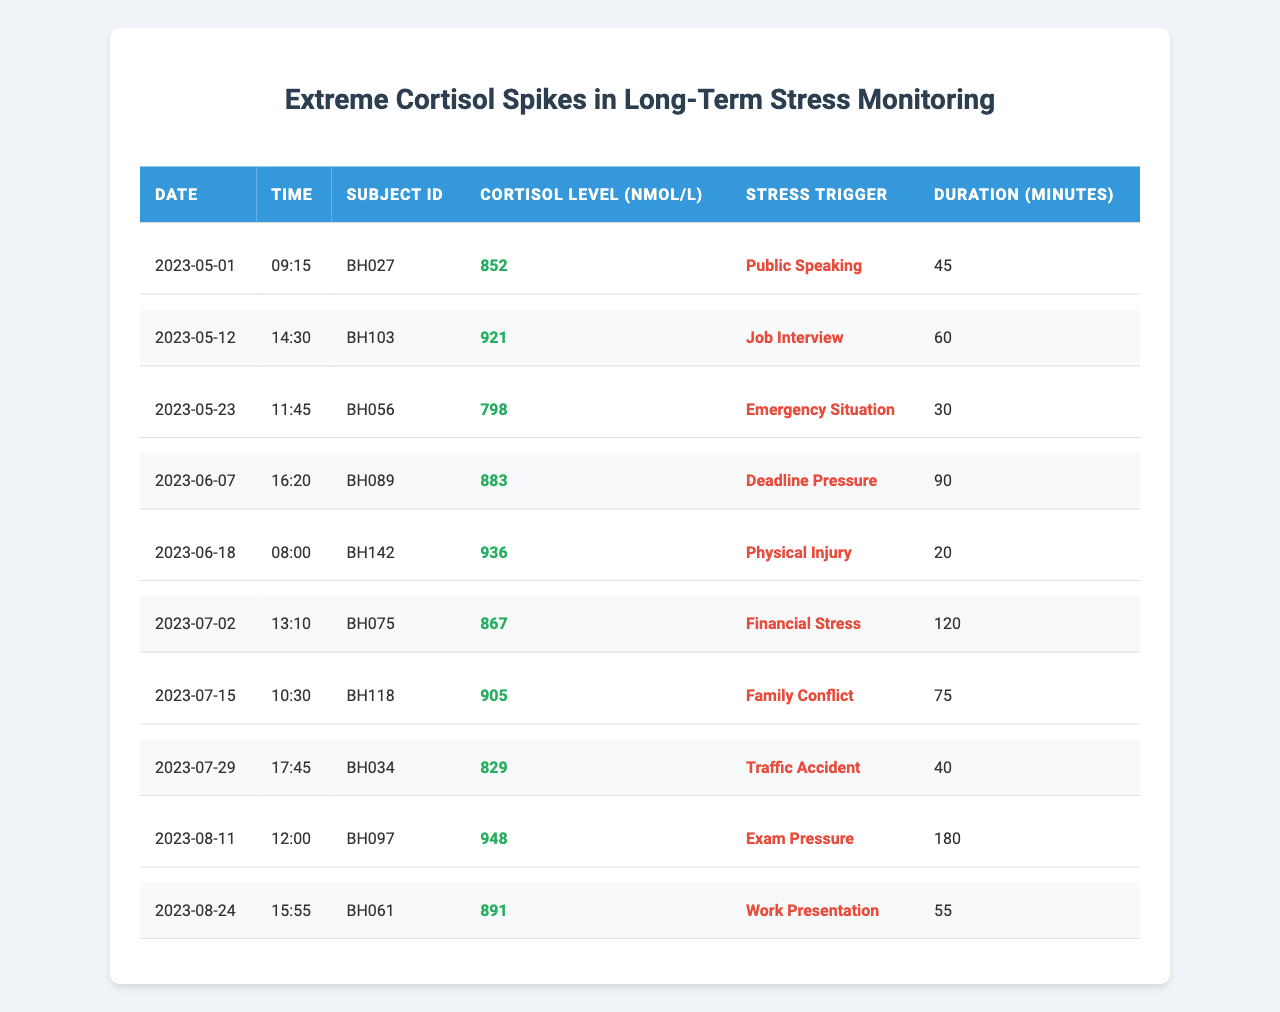What is the highest cortisol level recorded in the table? By examining the "Cortisol Level (nmol/L)" column, the highest value is 948 nmol/L, found on the date of 2023-08-11 during "Exam Pressure."
Answer: 948 nmol/L How many minutes did the subject experience "Financial Stress"? In the "Duration (minutes)" column, the entry for "Financial Stress" shows 120 minutes.
Answer: 120 minutes Is there any entry with a cortisol level above 900 nmol/L? Yes, there are multiple entries above 900 nmol/L: recorded cortisol levels are 921, 905, 936, and 948 nmol/L.
Answer: Yes What is the average cortisol level of all the entries listed? Adding up all cortisol levels: (852 + 921 + 798 + 883 + 936 + 867 + 905 + 829 + 948 + 891) = 8,030; dividing by the total number of entries (10) gives an average of 803.0 nmol/L.
Answer: 803 nmol/L Which stress trigger had the shortest duration recorded? Looking at the "Duration (minutes)" column, "Physical Injury" has the shortest duration recorded of 20 minutes.
Answer: 20 minutes How many subjects experienced cortisol spikes during "Public Speaking"? The "Subject ID" for "Public Speaking" is BH027, so only one subject experienced cortisol spikes during this trigger as recorded in the table.
Answer: 1 subject What is the sum of cortisol levels recorded for all entries involving "Family Conflict"? The only entry with "Family Conflict" shows a cortisol level of 905 nmol/L; therefore, the sum for this trigger is just 905 nmol/L.
Answer: 905 nmol/L Which dates had cortisol levels exceeding 850 nmol/L? The dates with cortisol levels exceeding 850 nmol/L are: 2023-05-12, 2023-06-18, 2023-08-11, and 2023-07-15.
Answer: Four dates Determine the difference in cortisol levels between the highest and lowest recorded levels. The highest level is 948 nmol/L, and the lowest is 798 nmol/L, so the difference is 948 - 798 = 150 nmol/L.
Answer: 150 nmol/L Which stress trigger was associated with the longest duration of stress? The longest duration is associated with "Exam Pressure," which lasted 180 minutes.
Answer: 180 minutes 